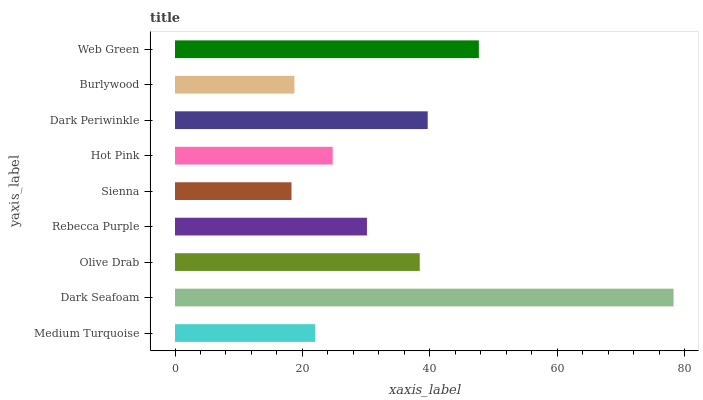Is Sienna the minimum?
Answer yes or no. Yes. Is Dark Seafoam the maximum?
Answer yes or no. Yes. Is Olive Drab the minimum?
Answer yes or no. No. Is Olive Drab the maximum?
Answer yes or no. No. Is Dark Seafoam greater than Olive Drab?
Answer yes or no. Yes. Is Olive Drab less than Dark Seafoam?
Answer yes or no. Yes. Is Olive Drab greater than Dark Seafoam?
Answer yes or no. No. Is Dark Seafoam less than Olive Drab?
Answer yes or no. No. Is Rebecca Purple the high median?
Answer yes or no. Yes. Is Rebecca Purple the low median?
Answer yes or no. Yes. Is Dark Seafoam the high median?
Answer yes or no. No. Is Dark Periwinkle the low median?
Answer yes or no. No. 